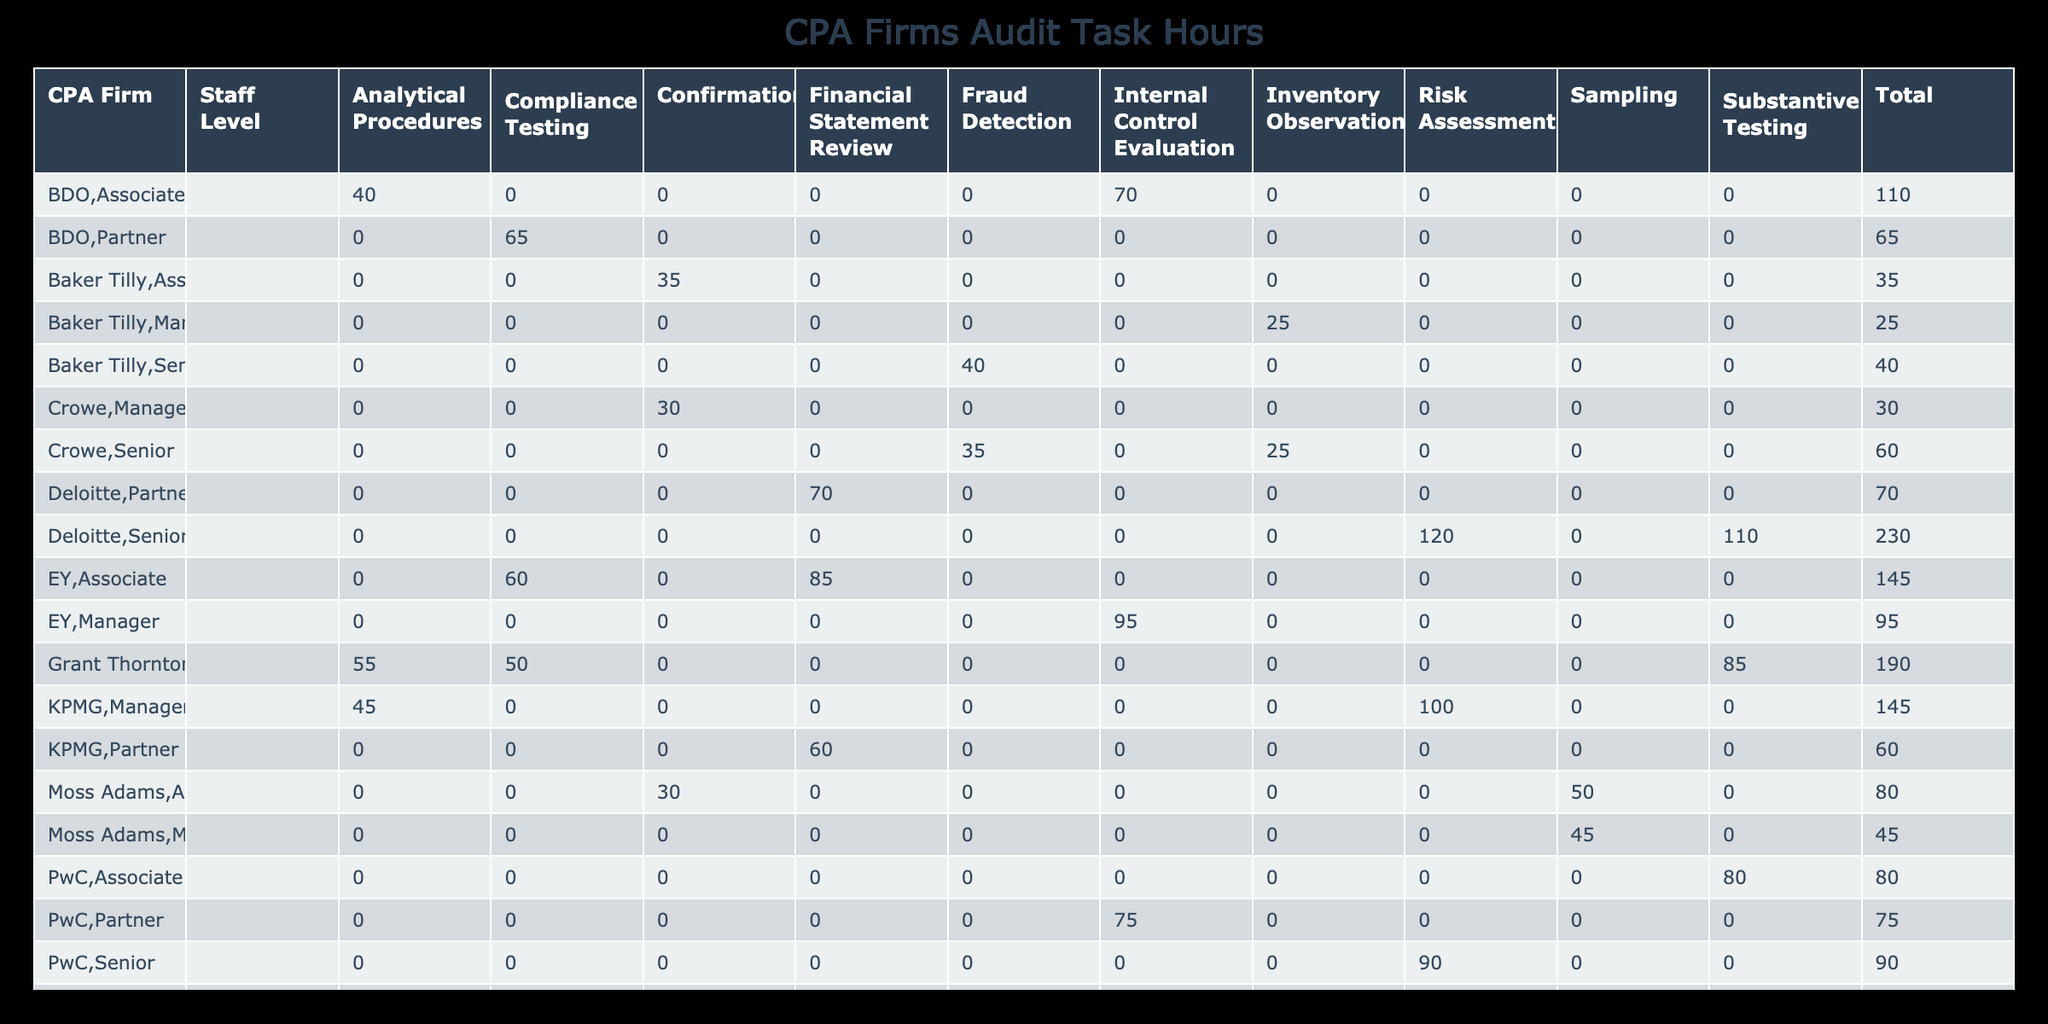What is the total number of hours spent by Deloitte on Risk Assessment? Deloitte spent 120 hours on Risk Assessment, which is specified in the table.
Answer: 120 How many hours did the Associate level staff at PwC spend on Internal Control Evaluation? PwC's Associate level staff spent 75 hours on Internal Control Evaluation, as shown in the table.
Answer: 75 Which CPA firm has the highest total hours spent on Substantive Testing? Deloitte spent 110 hours and Grant Thornton spent 85 hours on Substantive Testing; therefore, Deloitte has the highest total at 110 hours.
Answer: Deloitte What is the average number of hours spent on Compliance Testing across all CPA firms? The total hours spent on Compliance Testing are 60 (EY) + 65 (BDO) + 50 (Grant Thornton) = 175 hours. There are 3 firms involved, so the average is 175 / 3 = 58.33 hours.
Answer: 58.33 Did KPMG spend more hours on Financial Statement Review than on Risk Assessment? KPMG spent 60 hours on Financial Statement Review and 100 hours on Risk Assessment. Since 100 is greater than 60, the answer is no.
Answer: No Which staff level spent the least total hours on Analytical Procedures? From the table, BDO's Associate level staff spent 40 hours, while KPMG's Manager and EY's Associate staff spent 45 and 45 hours, respectively. Therefore, BDO's Associate spent the least.
Answer: BDO Associate What are the total hours spent by all CPA firms on Inventory Observation? The total hours spent on Inventory Observation are 25 (Crowe) + 20 (RSM) + 25 (Baker Tilly) = 70 hours.
Answer: 70 Is there a CPA firm with zero hours spent on Fraud Detection? By checking each firm's hours for Fraud Detection, RSM spent 30, Crowe spent 35, and Baker Tilly spent 40. Since all have hours recorded, the answer is no.
Answer: No Which CPA firm has the most diverse tasks reported in the table? By reviewing the tasks performed by each CPA firm, Deloitte has Risk Assessment, Substantive Testing, and Financial Statement Review, totaling 3 different tasks, thus showing more diversity than others.
Answer: Deloitte 